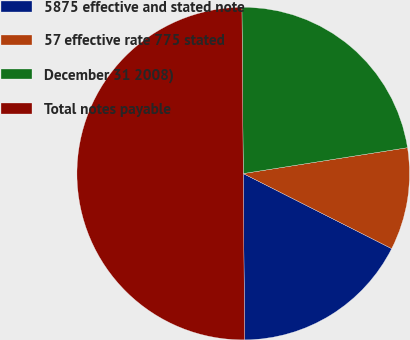Convert chart to OTSL. <chart><loc_0><loc_0><loc_500><loc_500><pie_chart><fcel>5875 effective and stated note<fcel>57 effective rate 775 stated<fcel>December 31 2008)<fcel>Total notes payable<nl><fcel>17.42%<fcel>9.94%<fcel>22.64%<fcel>50.0%<nl></chart> 